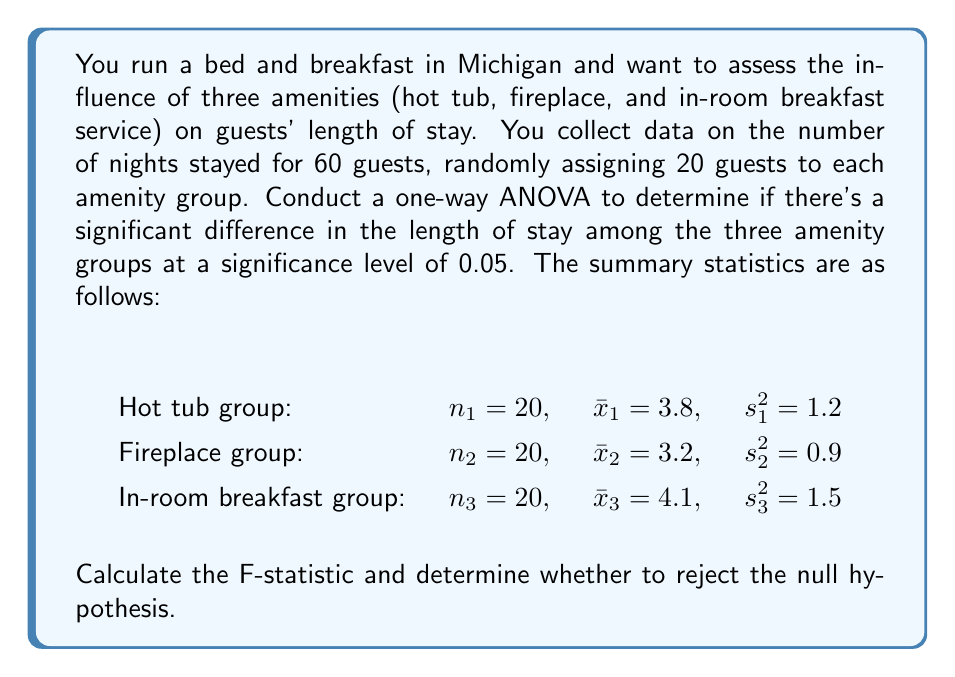What is the answer to this math problem? To conduct a one-way ANOVA, we need to follow these steps:

1. Calculate the total sum of squares (SST):
   $$SST = \sum_{i=1}^{3} (n_i - 1)s_i^2 + \sum_{i=1}^{3} n_i(\bar{x}_i - \bar{x})^2$$
   
   First, we need to find the grand mean $\bar{x}$:
   $$\bar{x} = \frac{20(3.8) + 20(3.2) + 20(4.1)}{60} = 3.7$$

   Now we can calculate SST:
   $$SST = 19(1.2) + 19(0.9) + 19(1.5) + 20(3.8 - 3.7)^2 + 20(3.2 - 3.7)^2 + 20(4.1 - 3.7)^2$$
   $$SST = 22.8 + 17.1 + 28.5 + 0.2 + 5 + 3.2 = 76.8$$

2. Calculate the between-group sum of squares (SSB):
   $$SSB = \sum_{i=1}^{3} n_i(\bar{x}_i - \bar{x})^2 = 0.2 + 5 + 3.2 = 8.4$$

3. Calculate the within-group sum of squares (SSW):
   $$SSW = SST - SSB = 76.8 - 8.4 = 68.4$$

4. Calculate the degrees of freedom:
   - Between groups: $df_B = k - 1 = 3 - 1 = 2$
   - Within groups: $df_W = N - k = 60 - 3 = 57$
   - Total: $df_T = N - 1 = 60 - 1 = 59$

5. Calculate the mean squares:
   $$MSB = \frac{SSB}{df_B} = \frac{8.4}{2} = 4.2$$
   $$MSW = \frac{SSW}{df_W} = \frac{68.4}{57} = 1.2$$

6. Calculate the F-statistic:
   $$F = \frac{MSB}{MSW} = \frac{4.2}{1.2} = 3.5$$

7. Determine the critical F-value:
   For $\alpha = 0.05$, $df_B = 2$, and $df_W = 57$, the critical F-value is approximately 3.16.

8. Compare the F-statistic to the critical F-value:
   Since $3.5 > 3.16$, we reject the null hypothesis.
Answer: The F-statistic is 3.5, which is greater than the critical F-value of 3.16. Therefore, we reject the null hypothesis at the 0.05 significance level. This suggests that there is a significant difference in the length of stay among the three amenity groups. 